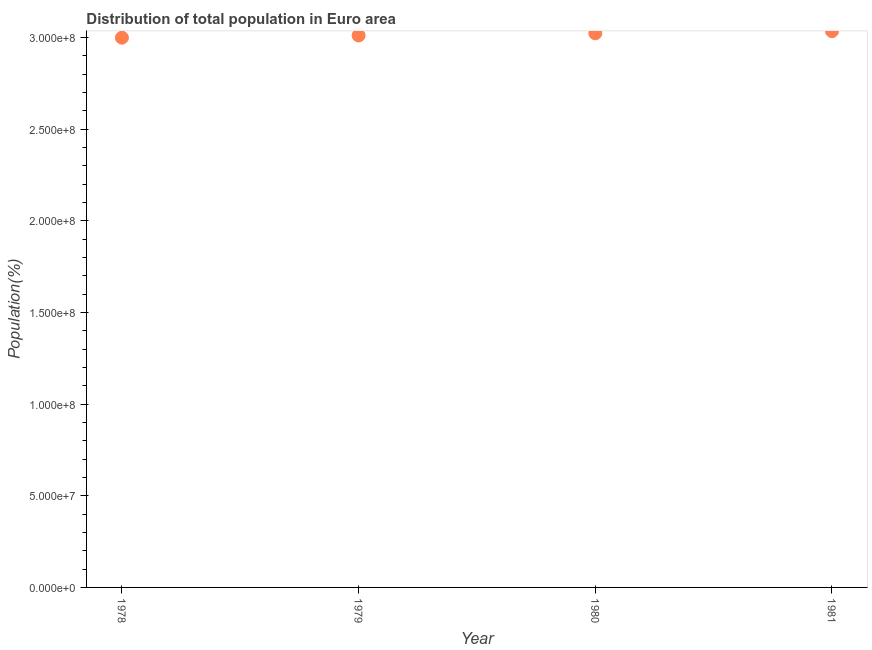What is the population in 1978?
Ensure brevity in your answer.  3.00e+08. Across all years, what is the maximum population?
Make the answer very short. 3.03e+08. Across all years, what is the minimum population?
Your answer should be very brief. 3.00e+08. In which year was the population maximum?
Ensure brevity in your answer.  1981. In which year was the population minimum?
Offer a terse response. 1978. What is the sum of the population?
Provide a short and direct response. 1.21e+09. What is the difference between the population in 1980 and 1981?
Your answer should be compact. -1.17e+06. What is the average population per year?
Provide a short and direct response. 3.02e+08. What is the median population?
Offer a terse response. 3.02e+08. In how many years, is the population greater than 260000000 %?
Your answer should be very brief. 4. What is the ratio of the population in 1978 to that in 1981?
Your answer should be very brief. 0.99. What is the difference between the highest and the second highest population?
Ensure brevity in your answer.  1.17e+06. What is the difference between the highest and the lowest population?
Your answer should be very brief. 3.56e+06. In how many years, is the population greater than the average population taken over all years?
Your response must be concise. 2. Does the population monotonically increase over the years?
Give a very brief answer. Yes. How many years are there in the graph?
Provide a short and direct response. 4. What is the difference between two consecutive major ticks on the Y-axis?
Provide a short and direct response. 5.00e+07. Are the values on the major ticks of Y-axis written in scientific E-notation?
Make the answer very short. Yes. Does the graph contain any zero values?
Offer a very short reply. No. Does the graph contain grids?
Offer a terse response. No. What is the title of the graph?
Offer a terse response. Distribution of total population in Euro area . What is the label or title of the X-axis?
Your answer should be very brief. Year. What is the label or title of the Y-axis?
Give a very brief answer. Population(%). What is the Population(%) in 1978?
Provide a short and direct response. 3.00e+08. What is the Population(%) in 1979?
Keep it short and to the point. 3.01e+08. What is the Population(%) in 1980?
Provide a succinct answer. 3.02e+08. What is the Population(%) in 1981?
Offer a very short reply. 3.03e+08. What is the difference between the Population(%) in 1978 and 1979?
Your answer should be very brief. -1.19e+06. What is the difference between the Population(%) in 1978 and 1980?
Ensure brevity in your answer.  -2.39e+06. What is the difference between the Population(%) in 1978 and 1981?
Ensure brevity in your answer.  -3.56e+06. What is the difference between the Population(%) in 1979 and 1980?
Provide a succinct answer. -1.20e+06. What is the difference between the Population(%) in 1979 and 1981?
Offer a terse response. -2.37e+06. What is the difference between the Population(%) in 1980 and 1981?
Offer a very short reply. -1.17e+06. What is the ratio of the Population(%) in 1978 to that in 1981?
Your answer should be very brief. 0.99. 